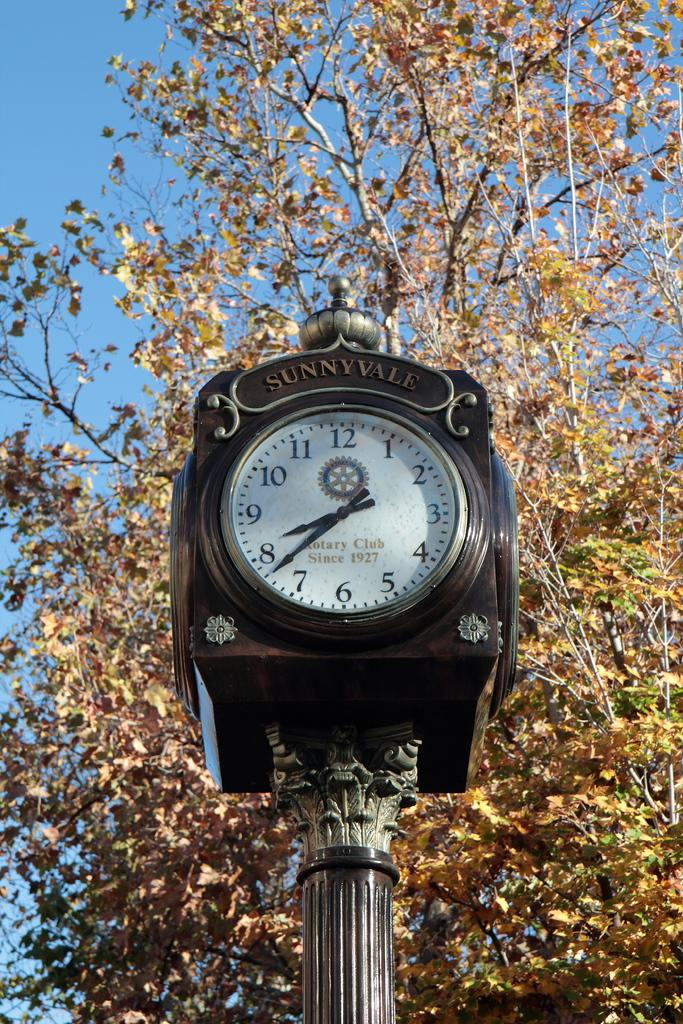<image>
Describe the image concisely. Clock in front of some trees which says "Sunnyvale" on top. 